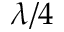<formula> <loc_0><loc_0><loc_500><loc_500>\lambda / 4</formula> 